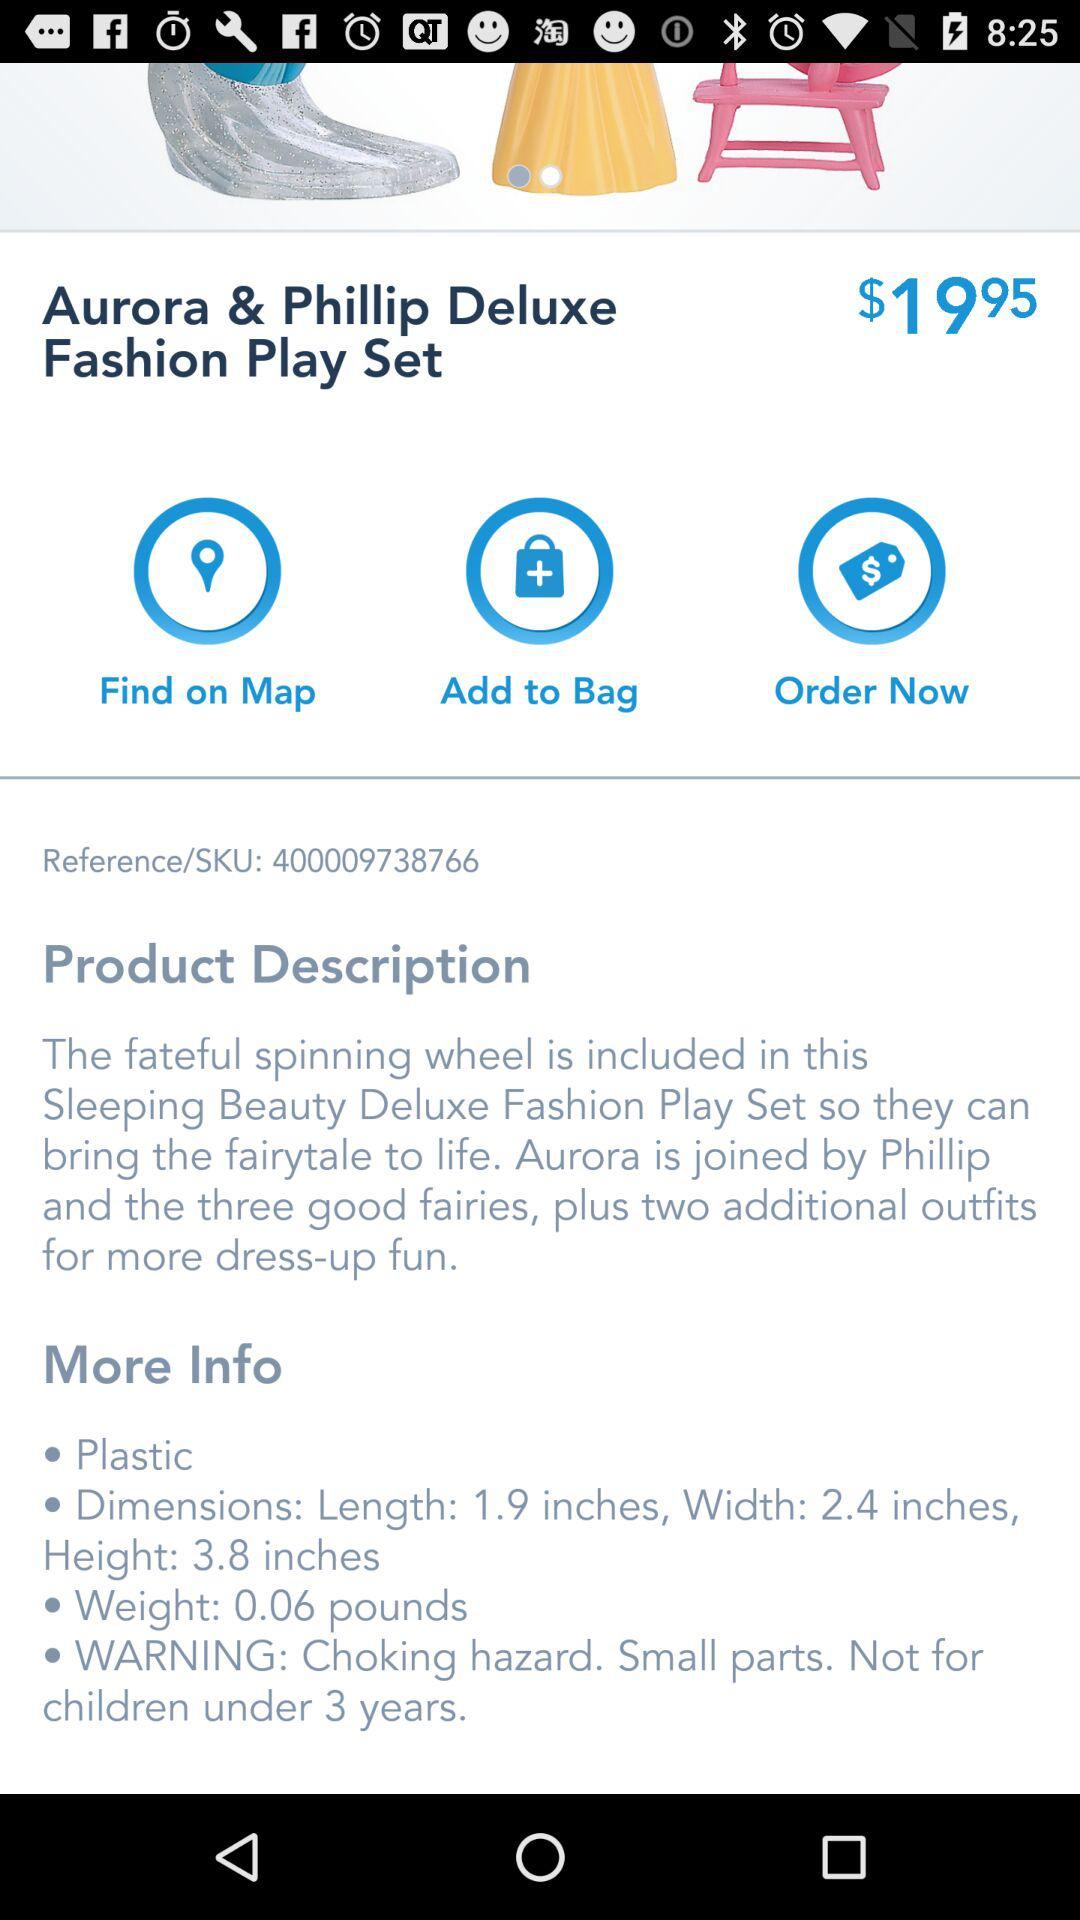What is the price of the Aurora & Phillip Deluxe Fashion Play Set? The price of the Aurora & Phillip Deluxe Fashion Play Set is $19.95. 